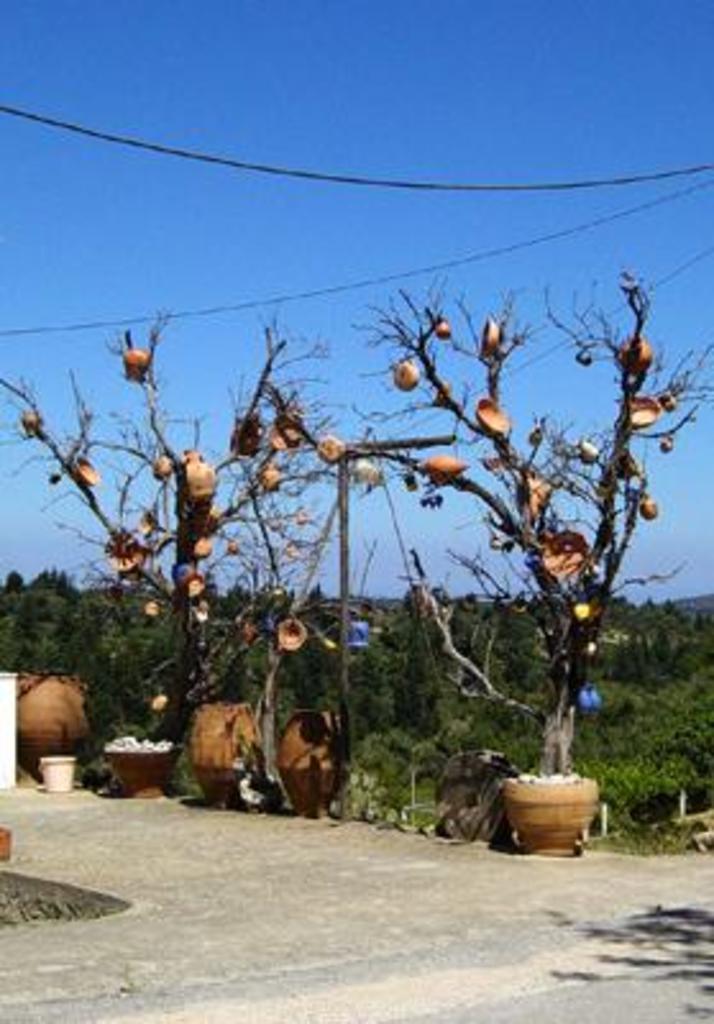Could you give a brief overview of what you see in this image? in this image there are some trees in the middle of this image and there is a sky at top of this image and there are some pots at bottom of this image. 